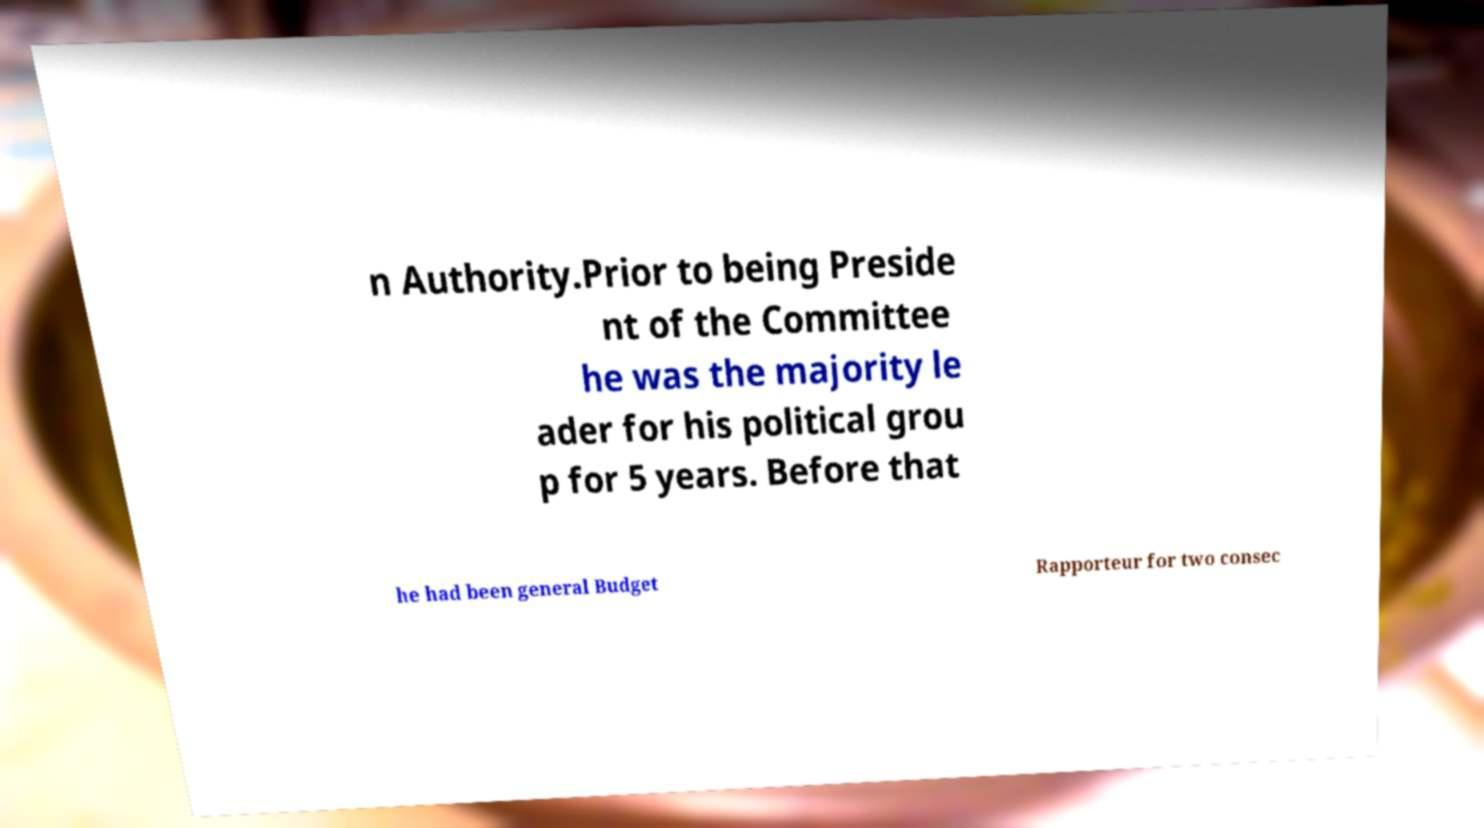Can you read and provide the text displayed in the image?This photo seems to have some interesting text. Can you extract and type it out for me? n Authority.Prior to being Preside nt of the Committee he was the majority le ader for his political grou p for 5 years. Before that he had been general Budget Rapporteur for two consec 